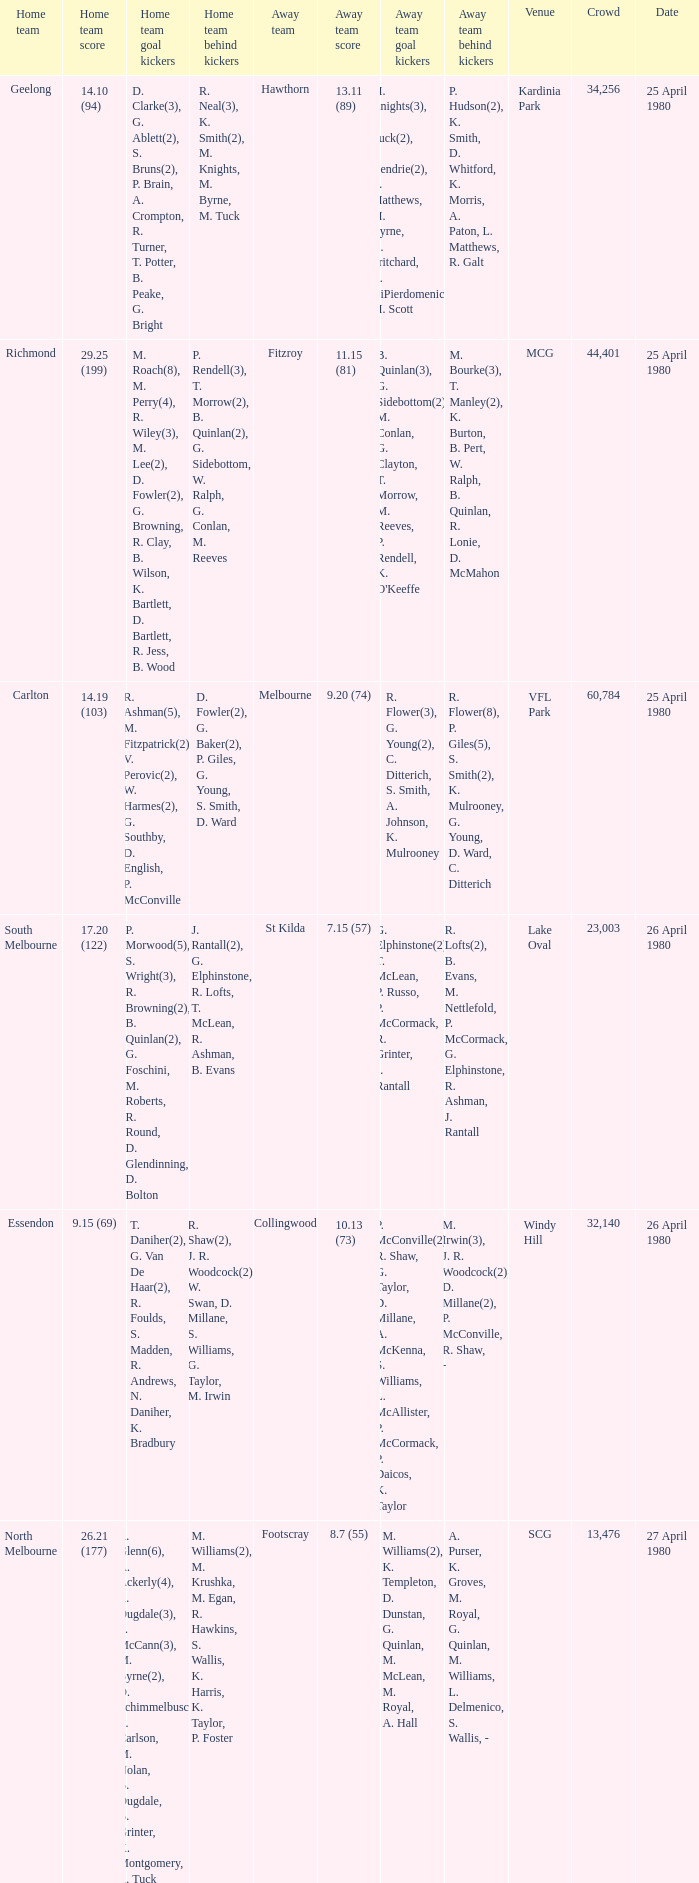On what date did the match at Lake Oval take place? 26 April 1980. 